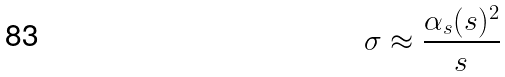<formula> <loc_0><loc_0><loc_500><loc_500>\sigma \approx \frac { \alpha _ { s } ( s ) ^ { 2 } } { s }</formula> 